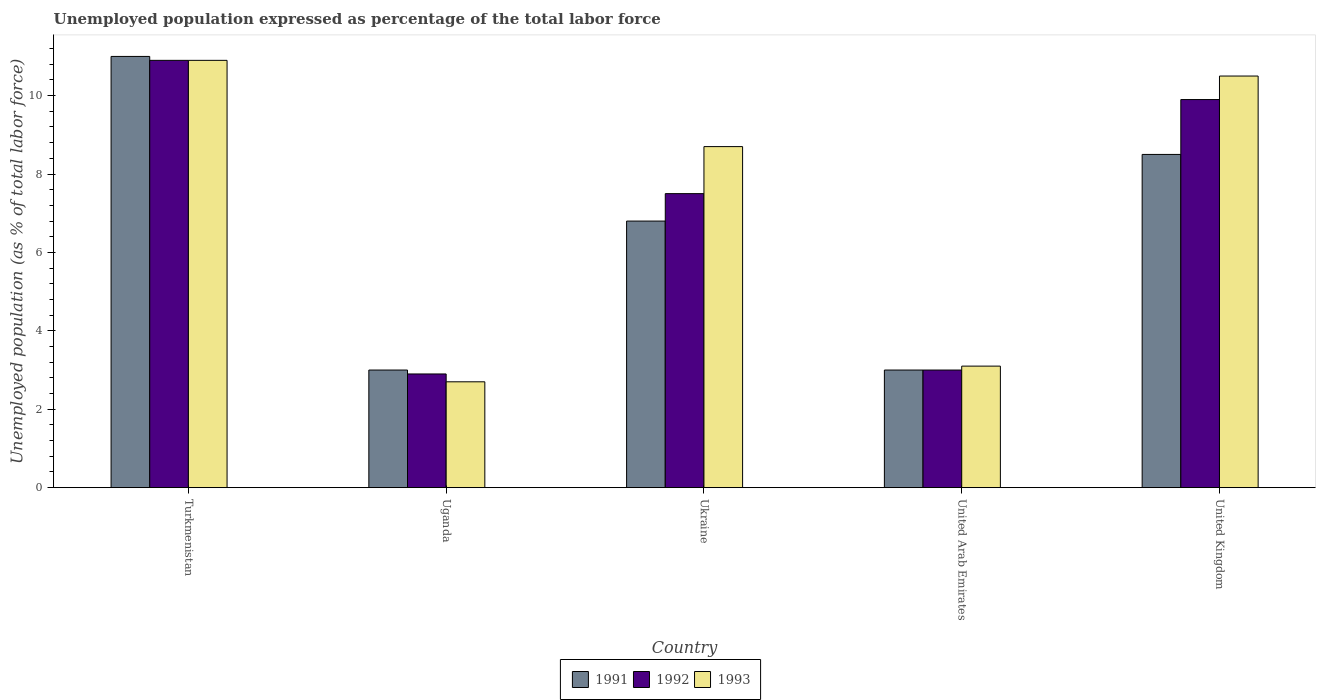How many groups of bars are there?
Keep it short and to the point. 5. Are the number of bars on each tick of the X-axis equal?
Provide a short and direct response. Yes. What is the label of the 2nd group of bars from the left?
Your answer should be compact. Uganda. What is the unemployment in in 1991 in United Kingdom?
Provide a short and direct response. 8.5. Across all countries, what is the maximum unemployment in in 1992?
Offer a terse response. 10.9. Across all countries, what is the minimum unemployment in in 1993?
Your answer should be very brief. 2.7. In which country was the unemployment in in 1991 maximum?
Offer a terse response. Turkmenistan. In which country was the unemployment in in 1992 minimum?
Your response must be concise. Uganda. What is the total unemployment in in 1991 in the graph?
Make the answer very short. 32.3. What is the difference between the unemployment in in 1993 in Uganda and that in United Kingdom?
Your answer should be compact. -7.8. What is the difference between the unemployment in in 1991 in United Arab Emirates and the unemployment in in 1992 in United Kingdom?
Ensure brevity in your answer.  -6.9. What is the average unemployment in in 1992 per country?
Keep it short and to the point. 6.84. What is the difference between the unemployment in of/in 1991 and unemployment in of/in 1993 in Uganda?
Offer a terse response. 0.3. What is the ratio of the unemployment in in 1993 in Turkmenistan to that in United Arab Emirates?
Your answer should be compact. 3.52. Is the difference between the unemployment in in 1991 in Turkmenistan and Uganda greater than the difference between the unemployment in in 1993 in Turkmenistan and Uganda?
Offer a very short reply. No. What is the difference between the highest and the second highest unemployment in in 1993?
Your answer should be compact. -2.2. What is the difference between the highest and the lowest unemployment in in 1992?
Your answer should be compact. 8. What does the 2nd bar from the left in United Arab Emirates represents?
Ensure brevity in your answer.  1992. What does the 2nd bar from the right in Ukraine represents?
Your response must be concise. 1992. How many bars are there?
Your answer should be compact. 15. What is the difference between two consecutive major ticks on the Y-axis?
Make the answer very short. 2. Are the values on the major ticks of Y-axis written in scientific E-notation?
Your answer should be compact. No. How many legend labels are there?
Your answer should be compact. 3. How are the legend labels stacked?
Offer a terse response. Horizontal. What is the title of the graph?
Give a very brief answer. Unemployed population expressed as percentage of the total labor force. Does "1999" appear as one of the legend labels in the graph?
Give a very brief answer. No. What is the label or title of the X-axis?
Your answer should be very brief. Country. What is the label or title of the Y-axis?
Your answer should be very brief. Unemployed population (as % of total labor force). What is the Unemployed population (as % of total labor force) in 1992 in Turkmenistan?
Keep it short and to the point. 10.9. What is the Unemployed population (as % of total labor force) of 1993 in Turkmenistan?
Ensure brevity in your answer.  10.9. What is the Unemployed population (as % of total labor force) in 1991 in Uganda?
Provide a succinct answer. 3. What is the Unemployed population (as % of total labor force) in 1992 in Uganda?
Keep it short and to the point. 2.9. What is the Unemployed population (as % of total labor force) in 1993 in Uganda?
Provide a short and direct response. 2.7. What is the Unemployed population (as % of total labor force) of 1991 in Ukraine?
Your response must be concise. 6.8. What is the Unemployed population (as % of total labor force) of 1992 in Ukraine?
Offer a very short reply. 7.5. What is the Unemployed population (as % of total labor force) in 1993 in Ukraine?
Give a very brief answer. 8.7. What is the Unemployed population (as % of total labor force) in 1991 in United Arab Emirates?
Ensure brevity in your answer.  3. What is the Unemployed population (as % of total labor force) of 1992 in United Arab Emirates?
Your answer should be very brief. 3. What is the Unemployed population (as % of total labor force) of 1993 in United Arab Emirates?
Give a very brief answer. 3.1. What is the Unemployed population (as % of total labor force) of 1991 in United Kingdom?
Your answer should be very brief. 8.5. What is the Unemployed population (as % of total labor force) of 1992 in United Kingdom?
Keep it short and to the point. 9.9. What is the Unemployed population (as % of total labor force) in 1993 in United Kingdom?
Ensure brevity in your answer.  10.5. Across all countries, what is the maximum Unemployed population (as % of total labor force) of 1991?
Give a very brief answer. 11. Across all countries, what is the maximum Unemployed population (as % of total labor force) in 1992?
Your response must be concise. 10.9. Across all countries, what is the maximum Unemployed population (as % of total labor force) in 1993?
Make the answer very short. 10.9. Across all countries, what is the minimum Unemployed population (as % of total labor force) of 1991?
Offer a terse response. 3. Across all countries, what is the minimum Unemployed population (as % of total labor force) of 1992?
Keep it short and to the point. 2.9. Across all countries, what is the minimum Unemployed population (as % of total labor force) of 1993?
Offer a very short reply. 2.7. What is the total Unemployed population (as % of total labor force) of 1991 in the graph?
Your response must be concise. 32.3. What is the total Unemployed population (as % of total labor force) of 1992 in the graph?
Provide a short and direct response. 34.2. What is the total Unemployed population (as % of total labor force) in 1993 in the graph?
Ensure brevity in your answer.  35.9. What is the difference between the Unemployed population (as % of total labor force) of 1992 in Turkmenistan and that in United Kingdom?
Your response must be concise. 1. What is the difference between the Unemployed population (as % of total labor force) in 1993 in Uganda and that in Ukraine?
Make the answer very short. -6. What is the difference between the Unemployed population (as % of total labor force) in 1991 in Uganda and that in United Arab Emirates?
Offer a very short reply. 0. What is the difference between the Unemployed population (as % of total labor force) in 1993 in Uganda and that in United Arab Emirates?
Offer a very short reply. -0.4. What is the difference between the Unemployed population (as % of total labor force) of 1991 in Uganda and that in United Kingdom?
Provide a succinct answer. -5.5. What is the difference between the Unemployed population (as % of total labor force) of 1991 in Ukraine and that in United Arab Emirates?
Offer a terse response. 3.8. What is the difference between the Unemployed population (as % of total labor force) of 1992 in Ukraine and that in United Arab Emirates?
Your answer should be very brief. 4.5. What is the difference between the Unemployed population (as % of total labor force) in 1993 in Ukraine and that in United Arab Emirates?
Ensure brevity in your answer.  5.6. What is the difference between the Unemployed population (as % of total labor force) of 1992 in Ukraine and that in United Kingdom?
Provide a succinct answer. -2.4. What is the difference between the Unemployed population (as % of total labor force) of 1991 in United Arab Emirates and that in United Kingdom?
Give a very brief answer. -5.5. What is the difference between the Unemployed population (as % of total labor force) in 1992 in Turkmenistan and the Unemployed population (as % of total labor force) in 1993 in Uganda?
Offer a very short reply. 8.2. What is the difference between the Unemployed population (as % of total labor force) of 1991 in Turkmenistan and the Unemployed population (as % of total labor force) of 1993 in Ukraine?
Make the answer very short. 2.3. What is the difference between the Unemployed population (as % of total labor force) in 1991 in Turkmenistan and the Unemployed population (as % of total labor force) in 1993 in United Arab Emirates?
Offer a very short reply. 7.9. What is the difference between the Unemployed population (as % of total labor force) in 1992 in Turkmenistan and the Unemployed population (as % of total labor force) in 1993 in United Arab Emirates?
Keep it short and to the point. 7.8. What is the difference between the Unemployed population (as % of total labor force) of 1991 in Turkmenistan and the Unemployed population (as % of total labor force) of 1992 in United Kingdom?
Your answer should be very brief. 1.1. What is the difference between the Unemployed population (as % of total labor force) in 1991 in Turkmenistan and the Unemployed population (as % of total labor force) in 1993 in United Kingdom?
Your answer should be compact. 0.5. What is the difference between the Unemployed population (as % of total labor force) in 1991 in Uganda and the Unemployed population (as % of total labor force) in 1992 in Ukraine?
Keep it short and to the point. -4.5. What is the difference between the Unemployed population (as % of total labor force) of 1991 in Uganda and the Unemployed population (as % of total labor force) of 1992 in United Arab Emirates?
Offer a terse response. 0. What is the difference between the Unemployed population (as % of total labor force) in 1991 in Uganda and the Unemployed population (as % of total labor force) in 1993 in United Arab Emirates?
Provide a succinct answer. -0.1. What is the difference between the Unemployed population (as % of total labor force) in 1991 in Uganda and the Unemployed population (as % of total labor force) in 1993 in United Kingdom?
Keep it short and to the point. -7.5. What is the difference between the Unemployed population (as % of total labor force) in 1991 in Ukraine and the Unemployed population (as % of total labor force) in 1992 in United Kingdom?
Give a very brief answer. -3.1. What is the difference between the Unemployed population (as % of total labor force) of 1991 in Ukraine and the Unemployed population (as % of total labor force) of 1993 in United Kingdom?
Provide a short and direct response. -3.7. What is the difference between the Unemployed population (as % of total labor force) of 1991 in United Arab Emirates and the Unemployed population (as % of total labor force) of 1993 in United Kingdom?
Provide a short and direct response. -7.5. What is the average Unemployed population (as % of total labor force) of 1991 per country?
Your response must be concise. 6.46. What is the average Unemployed population (as % of total labor force) of 1992 per country?
Provide a short and direct response. 6.84. What is the average Unemployed population (as % of total labor force) in 1993 per country?
Ensure brevity in your answer.  7.18. What is the difference between the Unemployed population (as % of total labor force) of 1991 and Unemployed population (as % of total labor force) of 1992 in Turkmenistan?
Provide a short and direct response. 0.1. What is the difference between the Unemployed population (as % of total labor force) of 1991 and Unemployed population (as % of total labor force) of 1993 in Turkmenistan?
Provide a succinct answer. 0.1. What is the difference between the Unemployed population (as % of total labor force) of 1991 and Unemployed population (as % of total labor force) of 1992 in Uganda?
Make the answer very short. 0.1. What is the difference between the Unemployed population (as % of total labor force) in 1991 and Unemployed population (as % of total labor force) in 1993 in Uganda?
Offer a very short reply. 0.3. What is the difference between the Unemployed population (as % of total labor force) in 1992 and Unemployed population (as % of total labor force) in 1993 in Uganda?
Keep it short and to the point. 0.2. What is the difference between the Unemployed population (as % of total labor force) in 1991 and Unemployed population (as % of total labor force) in 1992 in Ukraine?
Provide a short and direct response. -0.7. What is the difference between the Unemployed population (as % of total labor force) in 1991 and Unemployed population (as % of total labor force) in 1993 in United Arab Emirates?
Your response must be concise. -0.1. What is the difference between the Unemployed population (as % of total labor force) in 1991 and Unemployed population (as % of total labor force) in 1992 in United Kingdom?
Make the answer very short. -1.4. What is the difference between the Unemployed population (as % of total labor force) of 1991 and Unemployed population (as % of total labor force) of 1993 in United Kingdom?
Give a very brief answer. -2. What is the ratio of the Unemployed population (as % of total labor force) in 1991 in Turkmenistan to that in Uganda?
Make the answer very short. 3.67. What is the ratio of the Unemployed population (as % of total labor force) of 1992 in Turkmenistan to that in Uganda?
Ensure brevity in your answer.  3.76. What is the ratio of the Unemployed population (as % of total labor force) of 1993 in Turkmenistan to that in Uganda?
Your response must be concise. 4.04. What is the ratio of the Unemployed population (as % of total labor force) in 1991 in Turkmenistan to that in Ukraine?
Offer a terse response. 1.62. What is the ratio of the Unemployed population (as % of total labor force) in 1992 in Turkmenistan to that in Ukraine?
Keep it short and to the point. 1.45. What is the ratio of the Unemployed population (as % of total labor force) in 1993 in Turkmenistan to that in Ukraine?
Your answer should be very brief. 1.25. What is the ratio of the Unemployed population (as % of total labor force) in 1991 in Turkmenistan to that in United Arab Emirates?
Ensure brevity in your answer.  3.67. What is the ratio of the Unemployed population (as % of total labor force) in 1992 in Turkmenistan to that in United Arab Emirates?
Your answer should be compact. 3.63. What is the ratio of the Unemployed population (as % of total labor force) of 1993 in Turkmenistan to that in United Arab Emirates?
Offer a terse response. 3.52. What is the ratio of the Unemployed population (as % of total labor force) in 1991 in Turkmenistan to that in United Kingdom?
Ensure brevity in your answer.  1.29. What is the ratio of the Unemployed population (as % of total labor force) of 1992 in Turkmenistan to that in United Kingdom?
Your response must be concise. 1.1. What is the ratio of the Unemployed population (as % of total labor force) in 1993 in Turkmenistan to that in United Kingdom?
Offer a terse response. 1.04. What is the ratio of the Unemployed population (as % of total labor force) of 1991 in Uganda to that in Ukraine?
Your answer should be very brief. 0.44. What is the ratio of the Unemployed population (as % of total labor force) in 1992 in Uganda to that in Ukraine?
Ensure brevity in your answer.  0.39. What is the ratio of the Unemployed population (as % of total labor force) of 1993 in Uganda to that in Ukraine?
Your answer should be compact. 0.31. What is the ratio of the Unemployed population (as % of total labor force) of 1992 in Uganda to that in United Arab Emirates?
Keep it short and to the point. 0.97. What is the ratio of the Unemployed population (as % of total labor force) in 1993 in Uganda to that in United Arab Emirates?
Ensure brevity in your answer.  0.87. What is the ratio of the Unemployed population (as % of total labor force) of 1991 in Uganda to that in United Kingdom?
Your answer should be compact. 0.35. What is the ratio of the Unemployed population (as % of total labor force) in 1992 in Uganda to that in United Kingdom?
Offer a terse response. 0.29. What is the ratio of the Unemployed population (as % of total labor force) of 1993 in Uganda to that in United Kingdom?
Offer a very short reply. 0.26. What is the ratio of the Unemployed population (as % of total labor force) of 1991 in Ukraine to that in United Arab Emirates?
Give a very brief answer. 2.27. What is the ratio of the Unemployed population (as % of total labor force) of 1992 in Ukraine to that in United Arab Emirates?
Make the answer very short. 2.5. What is the ratio of the Unemployed population (as % of total labor force) of 1993 in Ukraine to that in United Arab Emirates?
Your response must be concise. 2.81. What is the ratio of the Unemployed population (as % of total labor force) of 1991 in Ukraine to that in United Kingdom?
Provide a succinct answer. 0.8. What is the ratio of the Unemployed population (as % of total labor force) of 1992 in Ukraine to that in United Kingdom?
Keep it short and to the point. 0.76. What is the ratio of the Unemployed population (as % of total labor force) in 1993 in Ukraine to that in United Kingdom?
Your answer should be very brief. 0.83. What is the ratio of the Unemployed population (as % of total labor force) of 1991 in United Arab Emirates to that in United Kingdom?
Provide a short and direct response. 0.35. What is the ratio of the Unemployed population (as % of total labor force) of 1992 in United Arab Emirates to that in United Kingdom?
Provide a succinct answer. 0.3. What is the ratio of the Unemployed population (as % of total labor force) of 1993 in United Arab Emirates to that in United Kingdom?
Offer a very short reply. 0.3. What is the difference between the highest and the second highest Unemployed population (as % of total labor force) of 1992?
Ensure brevity in your answer.  1. What is the difference between the highest and the second highest Unemployed population (as % of total labor force) in 1993?
Provide a short and direct response. 0.4. What is the difference between the highest and the lowest Unemployed population (as % of total labor force) of 1991?
Keep it short and to the point. 8. What is the difference between the highest and the lowest Unemployed population (as % of total labor force) of 1993?
Offer a terse response. 8.2. 